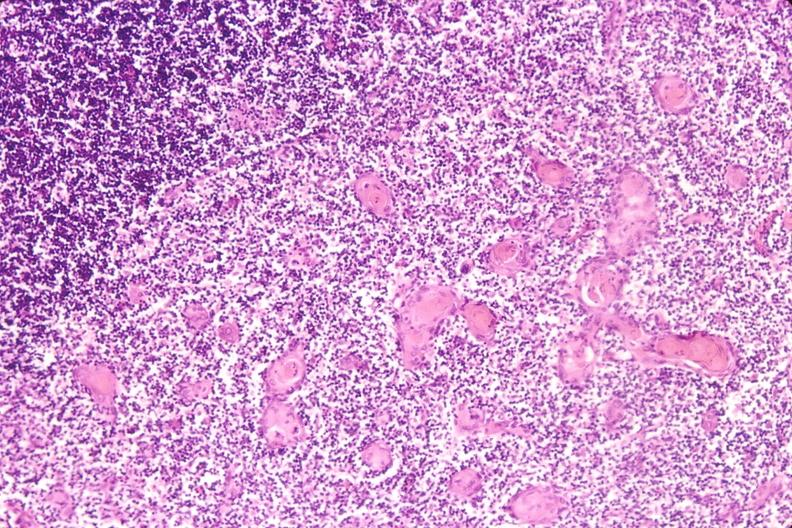what induce involution in baby with hyaline membrane disease?
Answer the question using a single word or phrase. Thymus, stress 